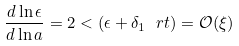<formula> <loc_0><loc_0><loc_500><loc_500>\frac { d \ln \epsilon } { d \ln a } = 2 < ( \epsilon + \delta _ { 1 } \ r t ) = \mathcal { O } ( \xi )</formula> 